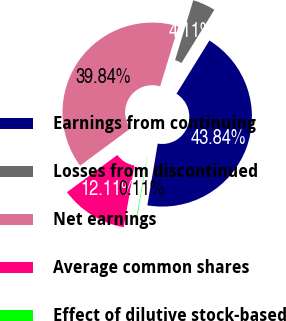Convert chart to OTSL. <chart><loc_0><loc_0><loc_500><loc_500><pie_chart><fcel>Earnings from continuing<fcel>Losses from discontinued<fcel>Net earnings<fcel>Average common shares<fcel>Effect of dilutive stock-based<nl><fcel>43.84%<fcel>4.11%<fcel>39.84%<fcel>12.11%<fcel>0.11%<nl></chart> 